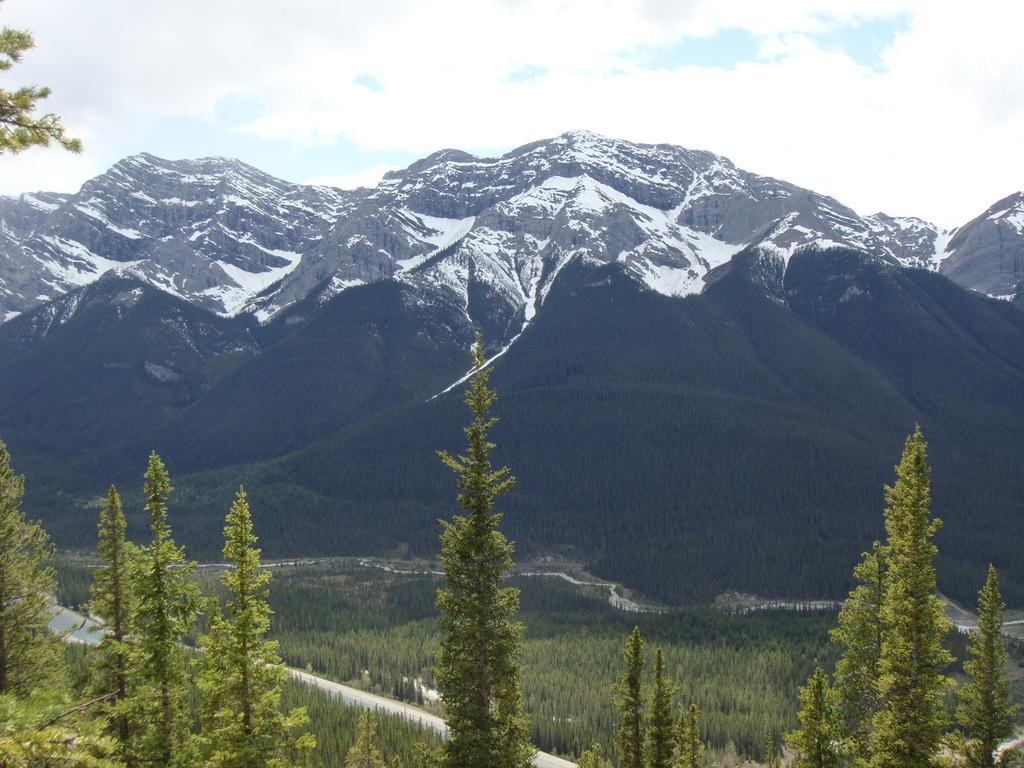Describe this image in one or two sentences. At the bottom of the image, we can see trees. Background we can see hills, trees, roads and snow. Top of the image, we can see the cloudy sky. 